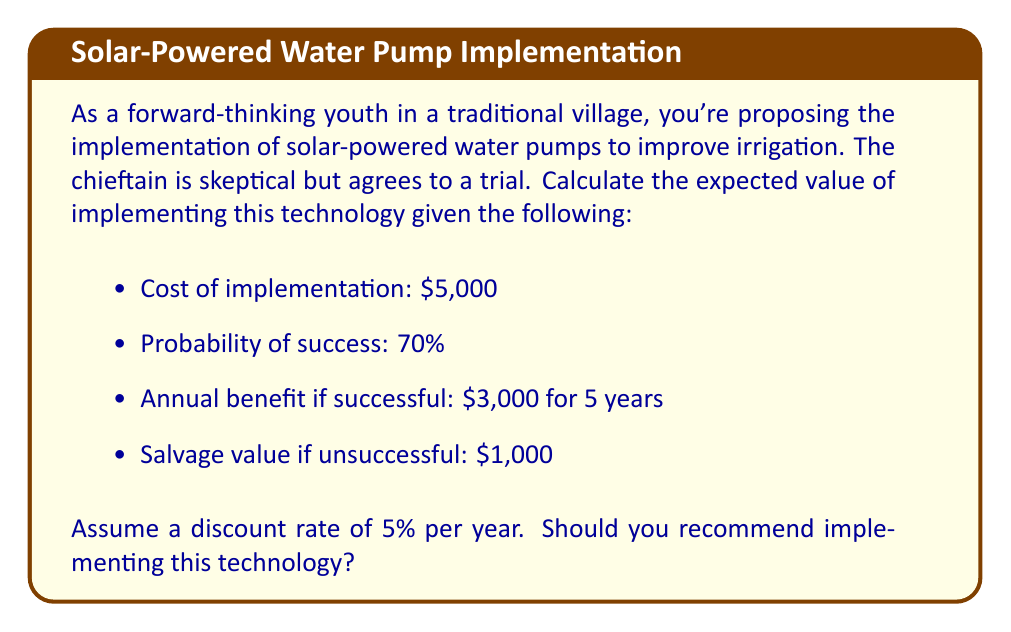Could you help me with this problem? To solve this problem, we need to calculate the expected value of implementing the solar-powered water pumps. We'll follow these steps:

1. Calculate the present value of successful implementation
2. Calculate the value of unsuccessful implementation
3. Compute the expected value using the probability of success
4. Compare the expected value to the implementation cost

Step 1: Present value of successful implementation

The annual benefit is $3,000 for 5 years. We need to calculate the present value of this stream of income using the given discount rate of 5%.

Present Value = $\sum_{t=1}^{5} \frac{3000}{(1+0.05)^t}$

Using the present value of an annuity formula:

PV = $3000 \cdot \frac{1 - (1+0.05)^{-5}}{0.05} = 12,977.74$

Step 2: Value of unsuccessful implementation

If unsuccessful, we only receive the salvage value of $1,000.

Step 3: Expected value calculation

Expected Value = (Probability of Success × Value if Successful) + (Probability of Failure × Value if Unsuccessful)

$EV = (0.70 \times 12,977.74) + (0.30 \times 1,000) = 9,084.42 + 300 = 9,384.42$

Step 4: Compare expected value to implementation cost

Net Expected Value = Expected Value - Implementation Cost
$NEV = 9,384.42 - 5,000 = 4,384.42$

Since the Net Expected Value is positive, implementing the technology is recommended.
Answer: The expected value of implementing the solar-powered water pumps is $9,384.42. Since this exceeds the implementation cost of $5,000, resulting in a positive net expected value of $4,384.42, you should recommend implementing this technology. 